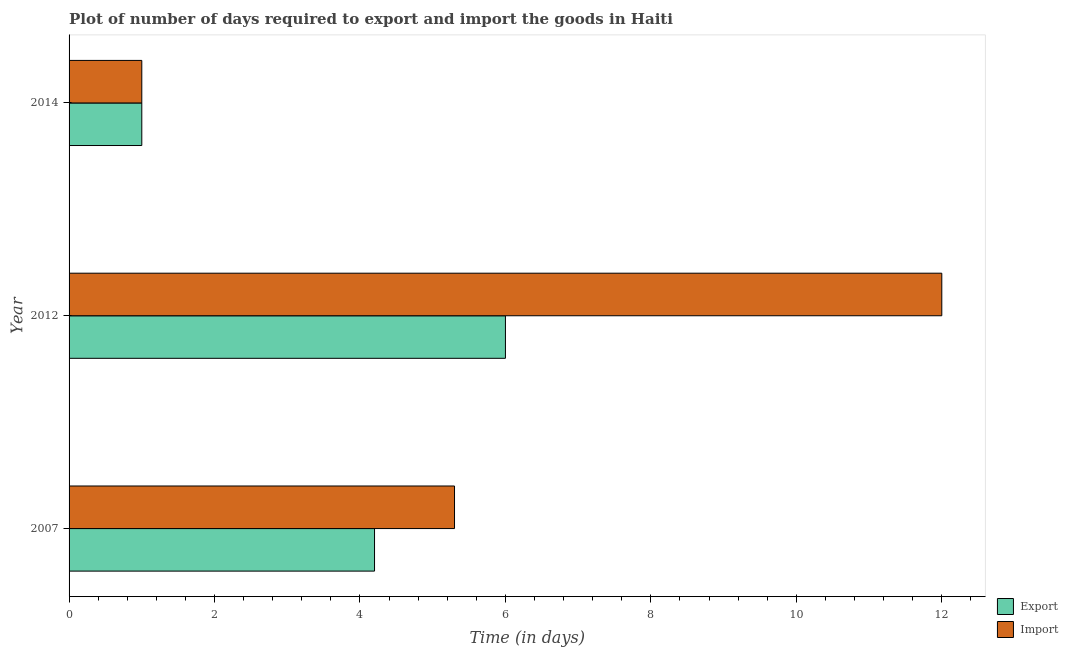How many groups of bars are there?
Your answer should be compact. 3. Are the number of bars per tick equal to the number of legend labels?
Your response must be concise. Yes. How many bars are there on the 3rd tick from the bottom?
Keep it short and to the point. 2. In how many cases, is the number of bars for a given year not equal to the number of legend labels?
Your response must be concise. 0. Across all years, what is the maximum time required to import?
Provide a short and direct response. 12. What is the difference between the time required to export in 2007 and that in 2014?
Ensure brevity in your answer.  3.2. What is the difference between the time required to import in 2014 and the time required to export in 2012?
Ensure brevity in your answer.  -5. What is the average time required to export per year?
Your answer should be very brief. 3.73. Is the difference between the time required to export in 2007 and 2012 greater than the difference between the time required to import in 2007 and 2012?
Your answer should be very brief. Yes. What is the difference between the highest and the second highest time required to import?
Offer a very short reply. 6.7. What is the difference between the highest and the lowest time required to export?
Make the answer very short. 5. In how many years, is the time required to import greater than the average time required to import taken over all years?
Offer a terse response. 1. Is the sum of the time required to import in 2007 and 2014 greater than the maximum time required to export across all years?
Provide a succinct answer. Yes. What does the 2nd bar from the top in 2007 represents?
Ensure brevity in your answer.  Export. What does the 2nd bar from the bottom in 2014 represents?
Keep it short and to the point. Import. Are all the bars in the graph horizontal?
Provide a short and direct response. Yes. What is the difference between two consecutive major ticks on the X-axis?
Ensure brevity in your answer.  2. Does the graph contain any zero values?
Keep it short and to the point. No. How many legend labels are there?
Keep it short and to the point. 2. How are the legend labels stacked?
Provide a short and direct response. Vertical. What is the title of the graph?
Give a very brief answer. Plot of number of days required to export and import the goods in Haiti. Does "Taxes" appear as one of the legend labels in the graph?
Your answer should be very brief. No. What is the label or title of the X-axis?
Offer a very short reply. Time (in days). What is the Time (in days) in Import in 2007?
Your response must be concise. 5.3. What is the Time (in days) in Export in 2014?
Your answer should be compact. 1. What is the Time (in days) of Import in 2014?
Make the answer very short. 1. Across all years, what is the maximum Time (in days) of Export?
Keep it short and to the point. 6. Across all years, what is the minimum Time (in days) in Export?
Offer a very short reply. 1. Across all years, what is the minimum Time (in days) of Import?
Your response must be concise. 1. What is the difference between the Time (in days) in Export in 2012 and that in 2014?
Give a very brief answer. 5. What is the difference between the Time (in days) of Import in 2012 and that in 2014?
Provide a succinct answer. 11. What is the difference between the Time (in days) in Export in 2007 and the Time (in days) in Import in 2012?
Your answer should be very brief. -7.8. What is the difference between the Time (in days) in Export in 2007 and the Time (in days) in Import in 2014?
Your response must be concise. 3.2. What is the difference between the Time (in days) in Export in 2012 and the Time (in days) in Import in 2014?
Provide a short and direct response. 5. What is the average Time (in days) in Export per year?
Your answer should be very brief. 3.73. In the year 2014, what is the difference between the Time (in days) in Export and Time (in days) in Import?
Offer a very short reply. 0. What is the ratio of the Time (in days) in Export in 2007 to that in 2012?
Your answer should be compact. 0.7. What is the ratio of the Time (in days) in Import in 2007 to that in 2012?
Your answer should be compact. 0.44. What is the ratio of the Time (in days) of Export in 2007 to that in 2014?
Ensure brevity in your answer.  4.2. What is the ratio of the Time (in days) in Import in 2007 to that in 2014?
Make the answer very short. 5.3. What is the ratio of the Time (in days) in Export in 2012 to that in 2014?
Provide a short and direct response. 6. What is the difference between the highest and the second highest Time (in days) of Import?
Your answer should be very brief. 6.7. What is the difference between the highest and the lowest Time (in days) of Import?
Your answer should be compact. 11. 